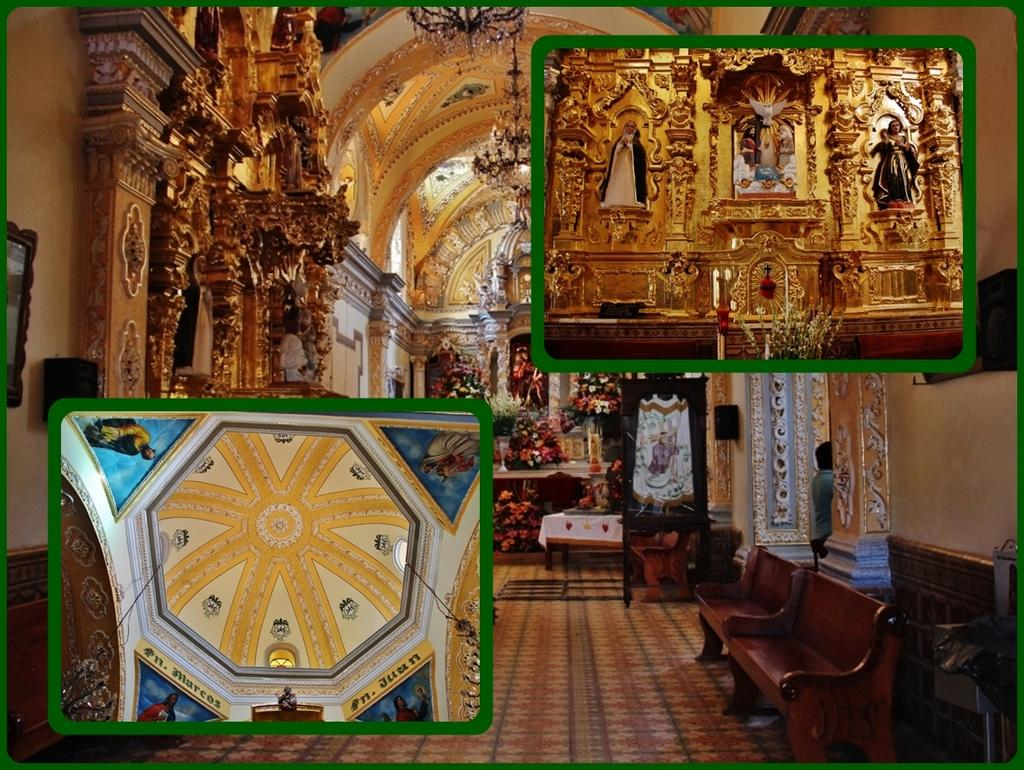What type of location is shown in the image? The image depicts the interior of a house. Are there any decorative elements visible in the image? Yes, there is a painting on the top of the house in one of the 3 images. Can you describe the presence of a person in the image? A person is standing at the side of the image. What type of coal is being used to heat the house in the image? There is no coal visible in the image, and the image does not depict any heating elements. 